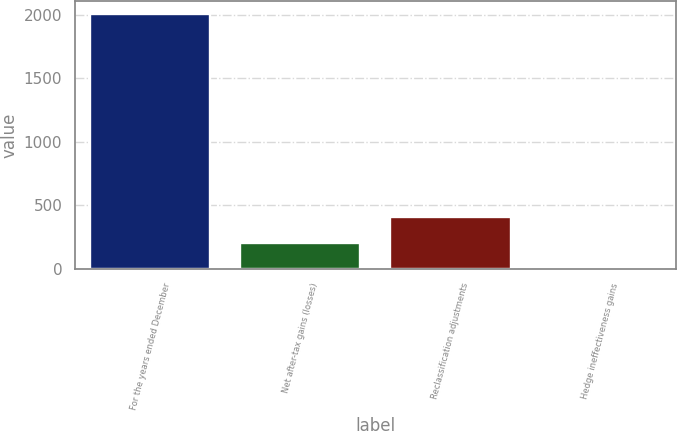Convert chart. <chart><loc_0><loc_0><loc_500><loc_500><bar_chart><fcel>For the years ended December<fcel>Net after-tax gains (losses)<fcel>Reclassification adjustments<fcel>Hedge ineffectiveness gains<nl><fcel>2005<fcel>202.3<fcel>402.6<fcel>2<nl></chart> 